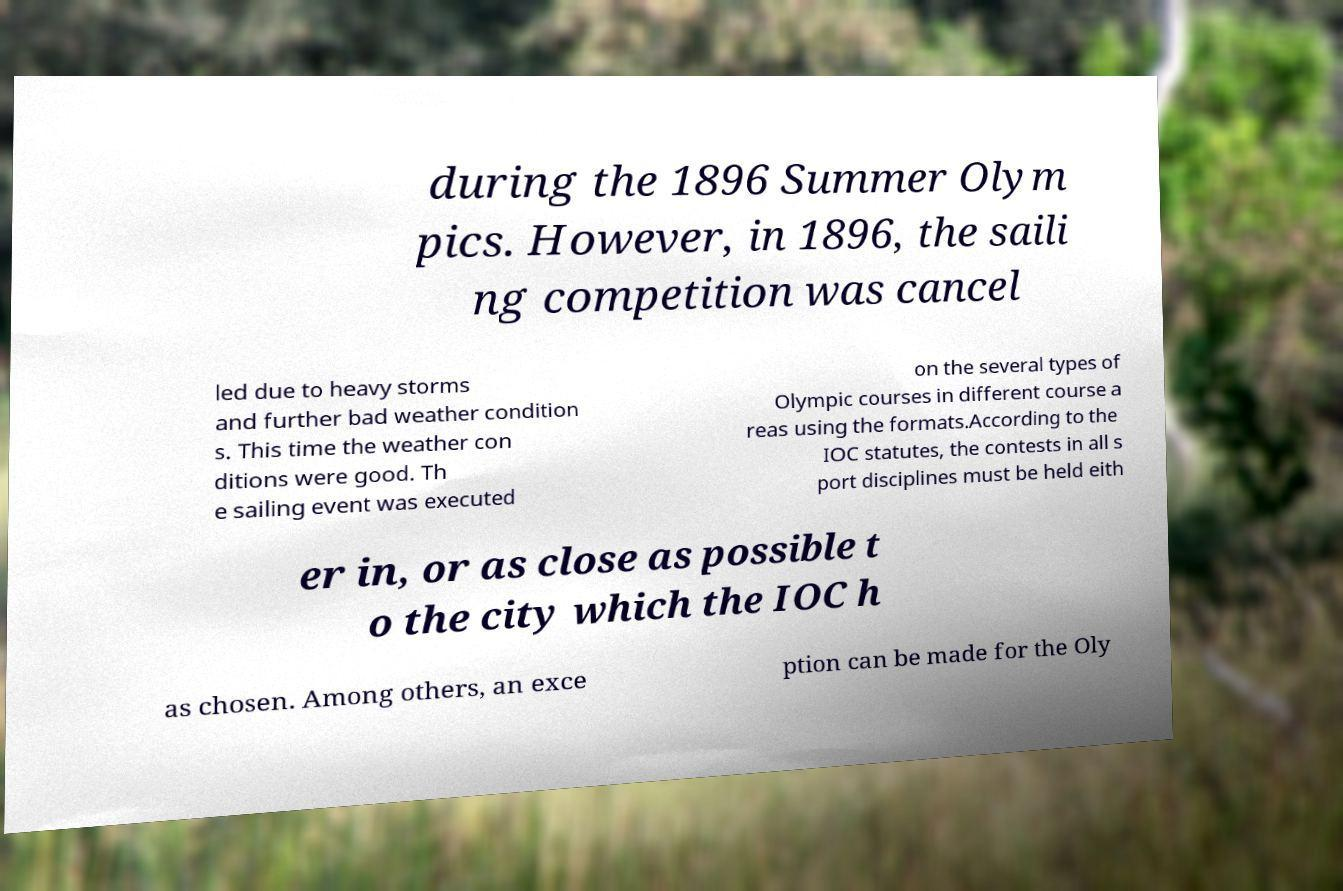Please identify and transcribe the text found in this image. during the 1896 Summer Olym pics. However, in 1896, the saili ng competition was cancel led due to heavy storms and further bad weather condition s. This time the weather con ditions were good. Th e sailing event was executed on the several types of Olympic courses in different course a reas using the formats.According to the IOC statutes, the contests in all s port disciplines must be held eith er in, or as close as possible t o the city which the IOC h as chosen. Among others, an exce ption can be made for the Oly 